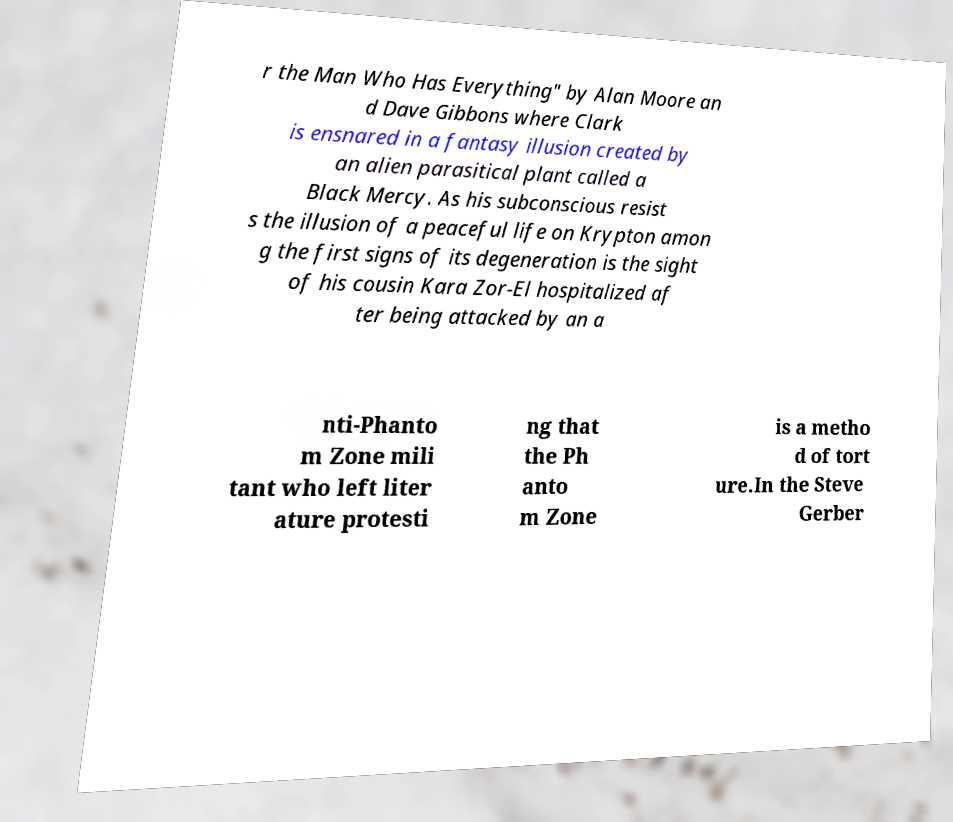Could you assist in decoding the text presented in this image and type it out clearly? r the Man Who Has Everything" by Alan Moore an d Dave Gibbons where Clark is ensnared in a fantasy illusion created by an alien parasitical plant called a Black Mercy. As his subconscious resist s the illusion of a peaceful life on Krypton amon g the first signs of its degeneration is the sight of his cousin Kara Zor-El hospitalized af ter being attacked by an a nti-Phanto m Zone mili tant who left liter ature protesti ng that the Ph anto m Zone is a metho d of tort ure.In the Steve Gerber 